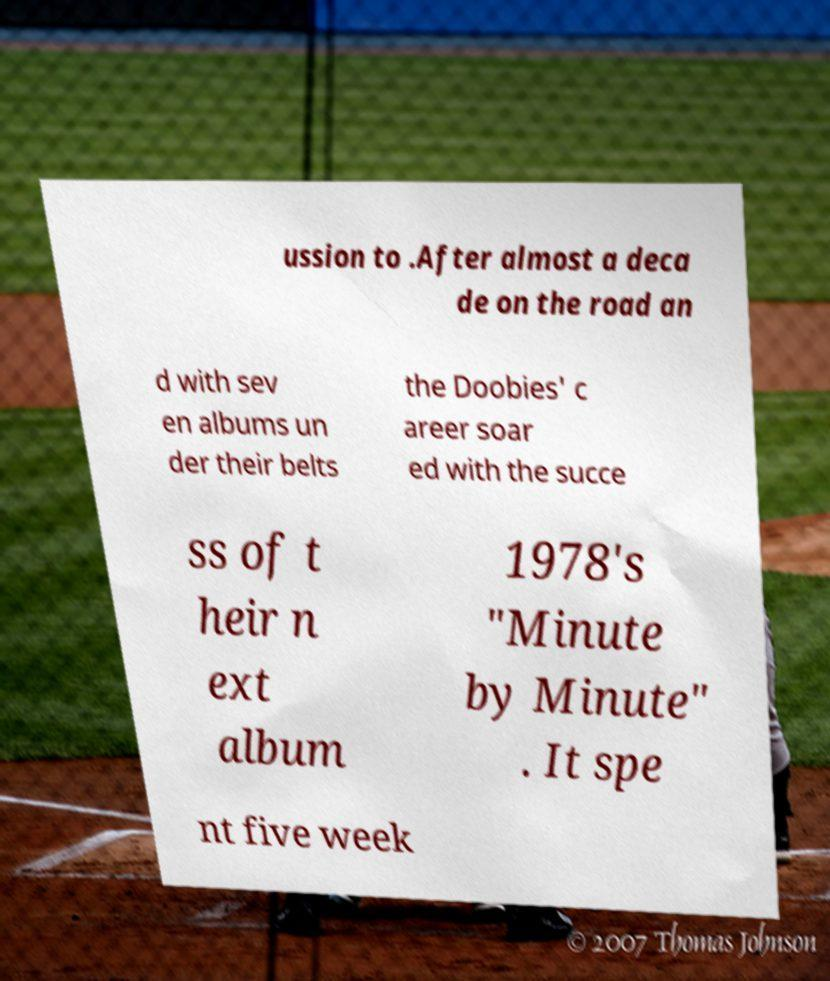For documentation purposes, I need the text within this image transcribed. Could you provide that? ussion to .After almost a deca de on the road an d with sev en albums un der their belts the Doobies' c areer soar ed with the succe ss of t heir n ext album 1978's "Minute by Minute" . It spe nt five week 